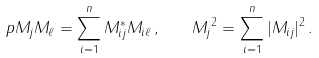Convert formula to latex. <formula><loc_0><loc_0><loc_500><loc_500>p { M _ { j } } { M _ { \ell } } = \sum _ { i = 1 } ^ { n } M _ { i j } ^ { * } M _ { i \ell } \, , \quad \| M _ { j } \| ^ { 2 } = \sum _ { i = 1 } ^ { n } | M _ { i j } | ^ { 2 } \, .</formula> 